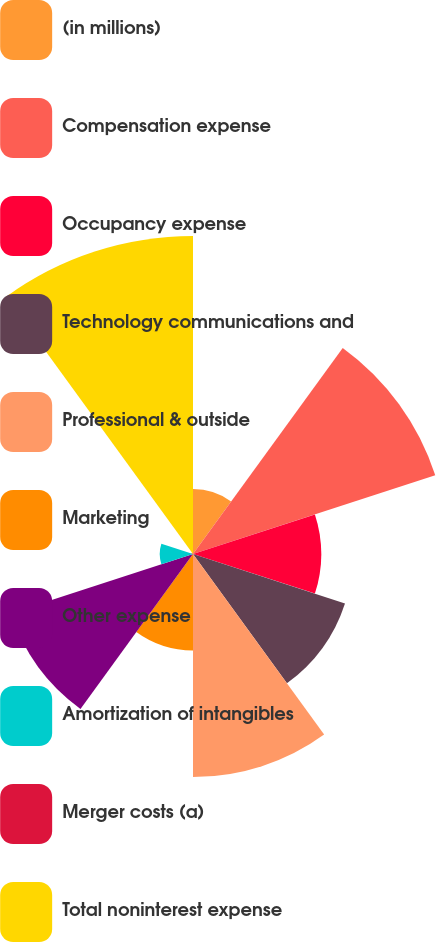Convert chart to OTSL. <chart><loc_0><loc_0><loc_500><loc_500><pie_chart><fcel>(in millions)<fcel>Compensation expense<fcel>Occupancy expense<fcel>Technology communications and<fcel>Professional & outside<fcel>Marketing<fcel>Other expense<fcel>Amortization of intangibles<fcel>Merger costs (a)<fcel>Total noninterest expense<nl><fcel>4.41%<fcel>17.31%<fcel>8.71%<fcel>10.86%<fcel>15.16%<fcel>6.56%<fcel>13.01%<fcel>2.26%<fcel>0.11%<fcel>21.61%<nl></chart> 